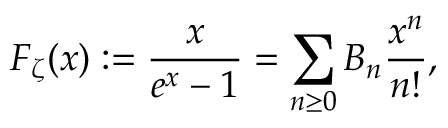<formula> <loc_0><loc_0><loc_500><loc_500>F _ { \zeta } ( x ) \colon = { \frac { x } { e ^ { x } - 1 } } = \sum _ { n \geq 0 } B _ { n } { \frac { x ^ { n } } { n ! } } ,</formula> 